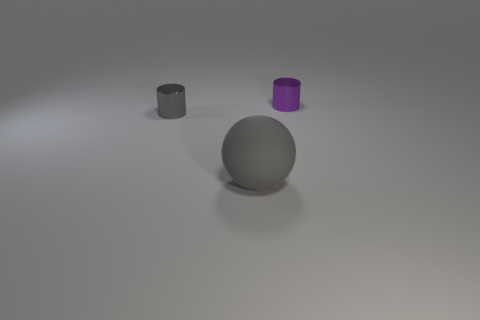Add 2 small blue rubber cylinders. How many objects exist? 5 Subtract all cylinders. How many objects are left? 1 Add 3 tiny purple metal cylinders. How many tiny purple metal cylinders are left? 4 Add 3 small purple rubber things. How many small purple rubber things exist? 3 Subtract 1 purple cylinders. How many objects are left? 2 Subtract all red objects. Subtract all purple metal cylinders. How many objects are left? 2 